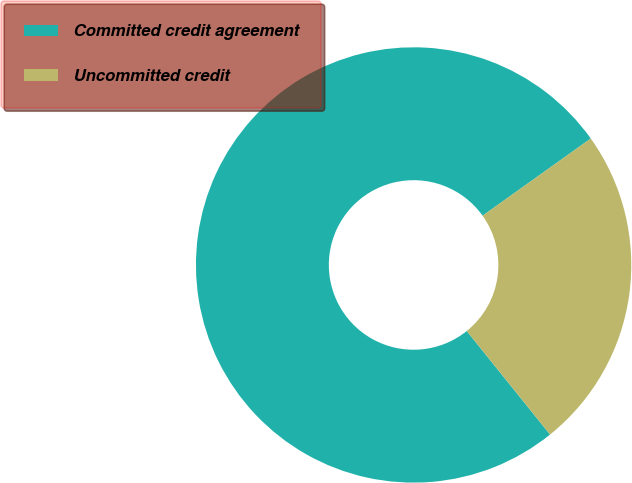Convert chart to OTSL. <chart><loc_0><loc_0><loc_500><loc_500><pie_chart><fcel>Committed credit agreement<fcel>Uncommitted credit<nl><fcel>75.92%<fcel>24.08%<nl></chart> 